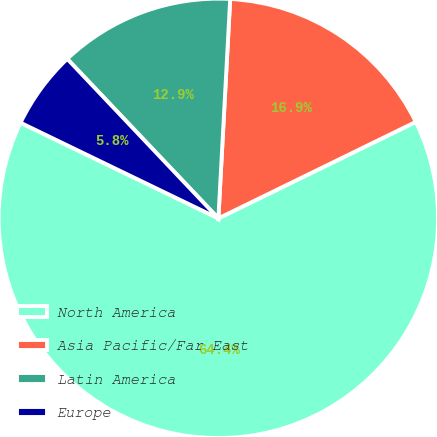Convert chart to OTSL. <chart><loc_0><loc_0><loc_500><loc_500><pie_chart><fcel>North America<fcel>Asia Pacific/Far East<fcel>Latin America<fcel>Europe<nl><fcel>64.41%<fcel>16.91%<fcel>12.93%<fcel>5.76%<nl></chart> 